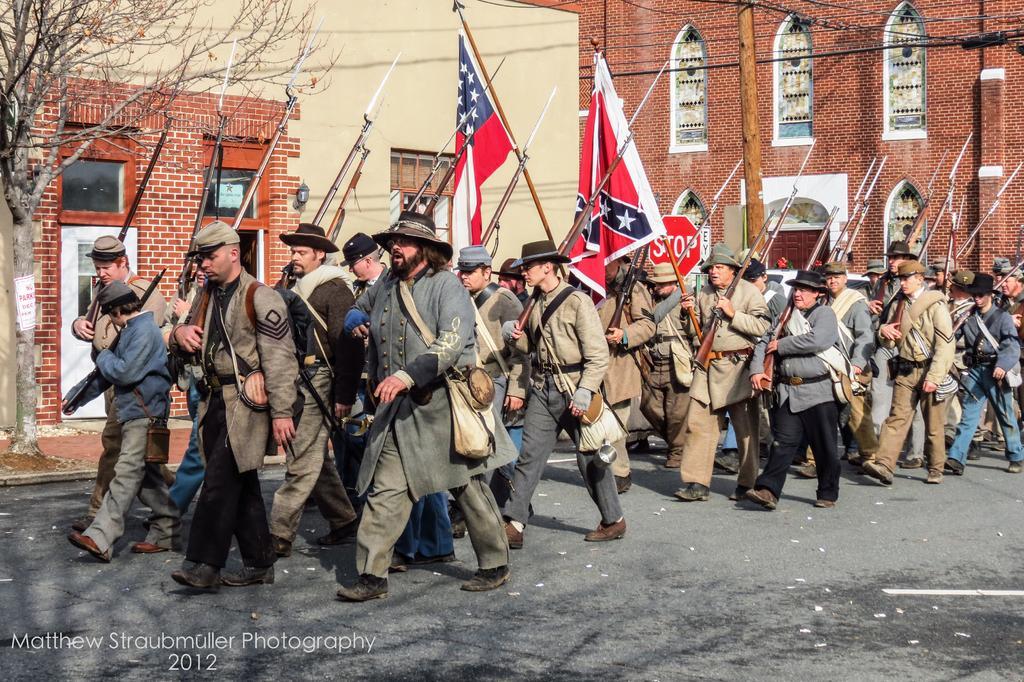Please provide a concise description of this image. In the picture we can see many people walking with costumes they are holding guns with knives to it and behind them, we can see building walls with bricks and we can also see a tree on the path which is dried. 